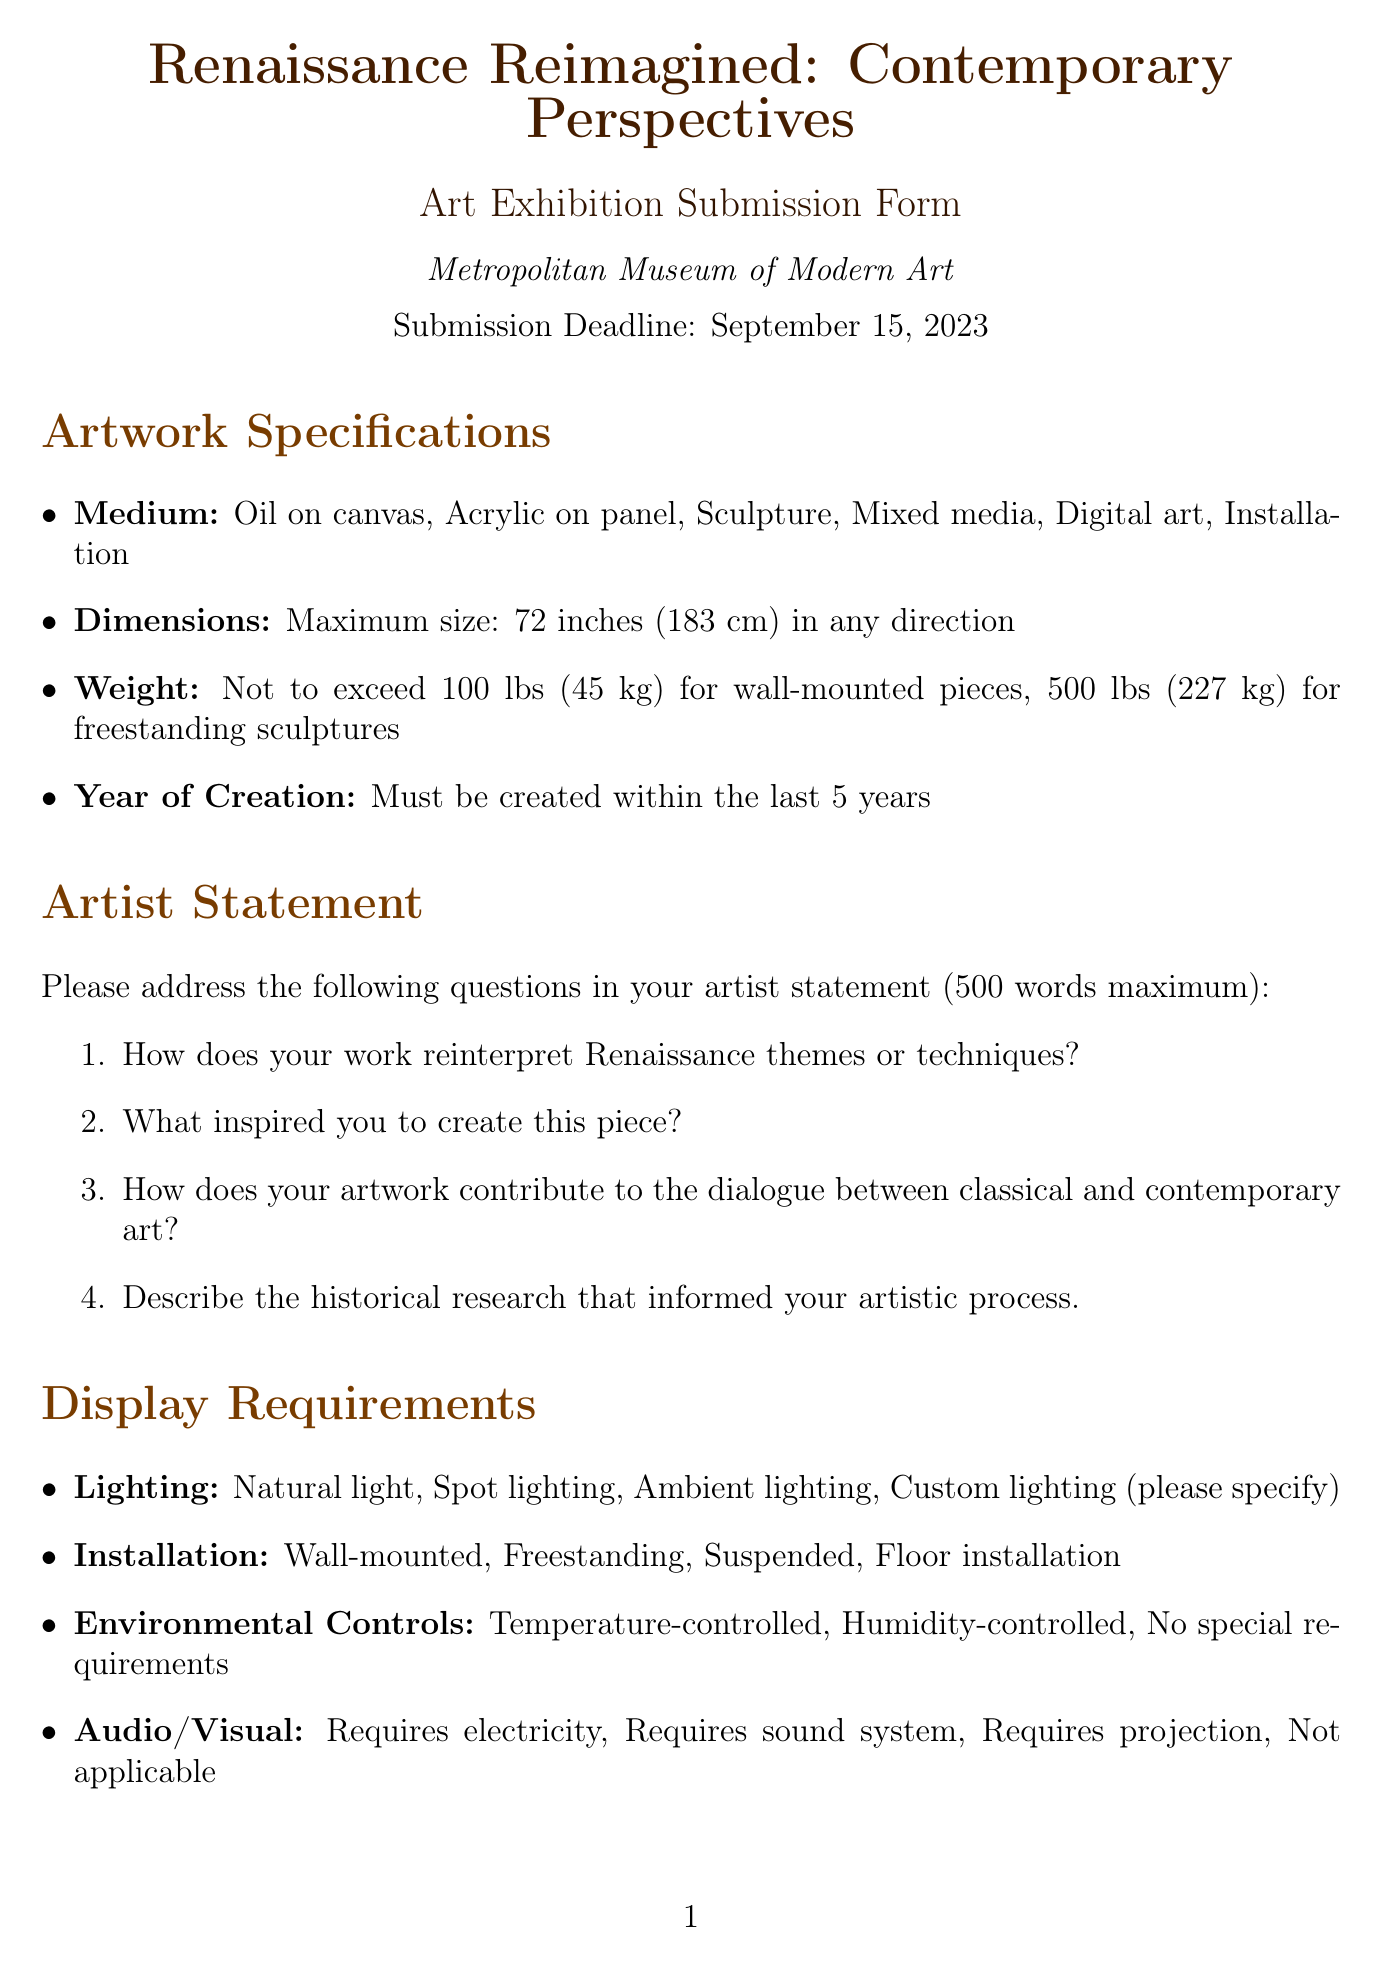What is the title of the exhibition? The title of the exhibition is mentioned in the document's header.
Answer: Renaissance Reimagined: Contemporary Perspectives What is the submission deadline? The document specifies the date by which submissions must be received.
Answer: September 15, 2023 What is the maximum weight for wall-mounted pieces? The document provides specific weight restrictions for different types of artwork.
Answer: 100 lbs (45 kg) Which type of artwork must be created in the last five years? The document outlines what is required for the year of creation of the artwork.
Answer: Year of Creation How many prompt questions are listed for the artist statement? The document enumerates the questions that artists must answer in their statement.
Answer: 4 What is one of the evaluation criteria for submissions? The document specifies criteria that will be used to assess submissions.
Answer: Historical accuracy and depth of research List one option for environmental controls. The document includes different requirements for environmental settings for displayed art.
Answer: Temperature-controlled What must artists provide to support their submission regarding authenticity? The document details requirements concerning the originality of submitted works.
Answer: Statement on the authenticity and originality of your work Who is one notable juror mentioned in the document? The document lists individuals who will be evaluating the submissions.
Answer: Dr. Elizabeth Cropper 